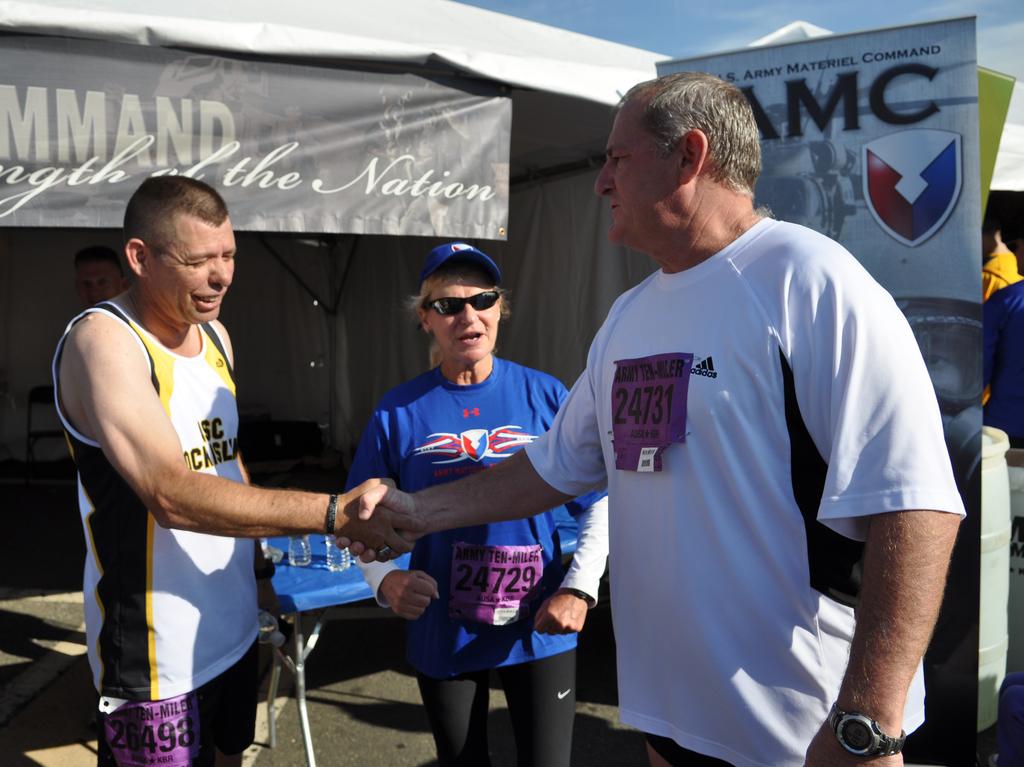What is the number of the man on right?
Provide a short and direct response. 24731. 